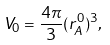<formula> <loc_0><loc_0><loc_500><loc_500>V _ { 0 } = \frac { 4 \pi } { 3 } ( r _ { A } ^ { 0 } ) ^ { 3 } ,</formula> 